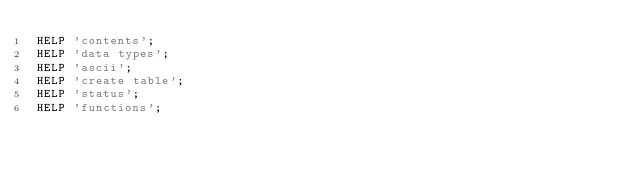Convert code to text. <code><loc_0><loc_0><loc_500><loc_500><_SQL_>HELP 'contents';
HELP 'data types';
HELP 'ascii';
HELP 'create table';
HELP 'status';
HELP 'functions';
</code> 